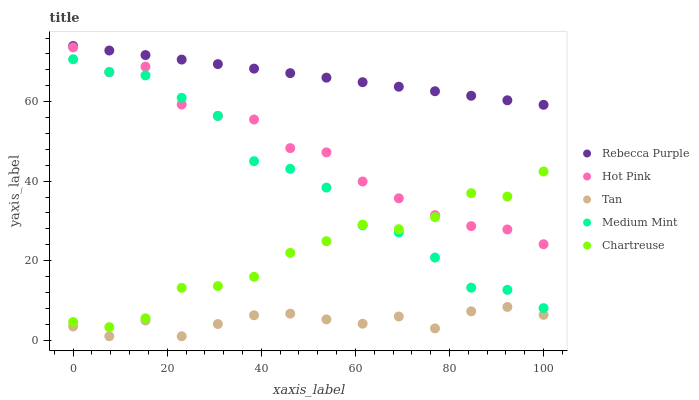Does Tan have the minimum area under the curve?
Answer yes or no. Yes. Does Rebecca Purple have the maximum area under the curve?
Answer yes or no. Yes. Does Hot Pink have the minimum area under the curve?
Answer yes or no. No. Does Hot Pink have the maximum area under the curve?
Answer yes or no. No. Is Rebecca Purple the smoothest?
Answer yes or no. Yes. Is Medium Mint the roughest?
Answer yes or no. Yes. Is Tan the smoothest?
Answer yes or no. No. Is Tan the roughest?
Answer yes or no. No. Does Tan have the lowest value?
Answer yes or no. Yes. Does Hot Pink have the lowest value?
Answer yes or no. No. Does Rebecca Purple have the highest value?
Answer yes or no. Yes. Does Hot Pink have the highest value?
Answer yes or no. No. Is Tan less than Hot Pink?
Answer yes or no. Yes. Is Hot Pink greater than Tan?
Answer yes or no. Yes. Does Hot Pink intersect Medium Mint?
Answer yes or no. Yes. Is Hot Pink less than Medium Mint?
Answer yes or no. No. Is Hot Pink greater than Medium Mint?
Answer yes or no. No. Does Tan intersect Hot Pink?
Answer yes or no. No. 